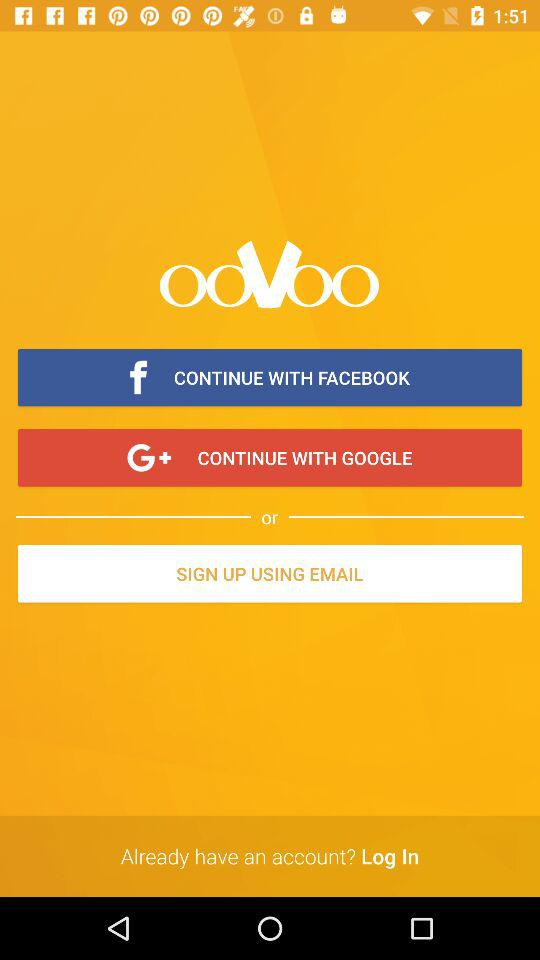What is the application name? The application name is "ooVoo". 